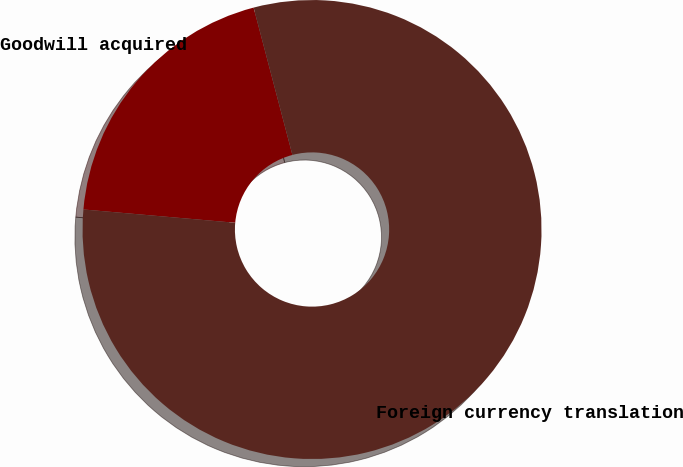<chart> <loc_0><loc_0><loc_500><loc_500><pie_chart><fcel>Goodwill acquired<fcel>Foreign currency translation<nl><fcel>19.51%<fcel>80.49%<nl></chart> 